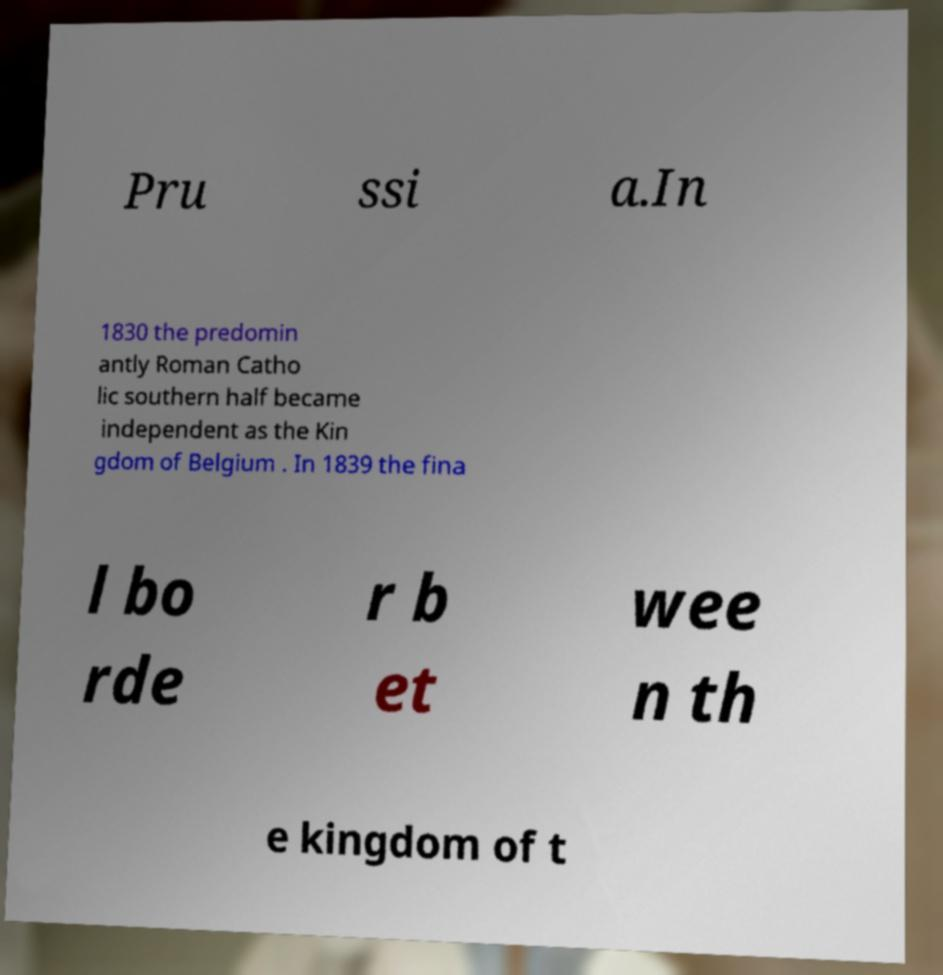Please read and relay the text visible in this image. What does it say? Pru ssi a.In 1830 the predomin antly Roman Catho lic southern half became independent as the Kin gdom of Belgium . In 1839 the fina l bo rde r b et wee n th e kingdom of t 